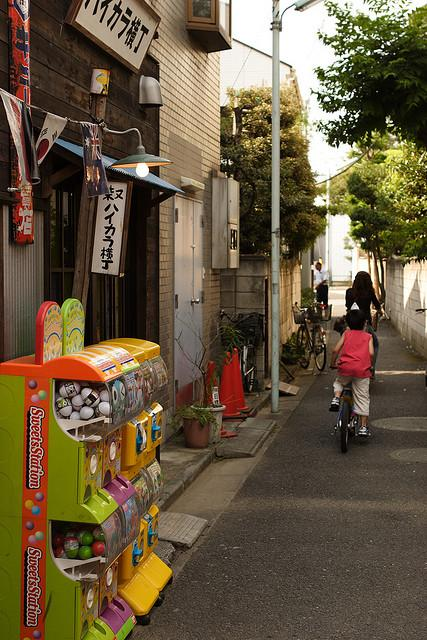What are the colorful machines called?

Choices:
A) garbage bins
B) mailboxes
C) vending machines
D) storage lockers vending machines 